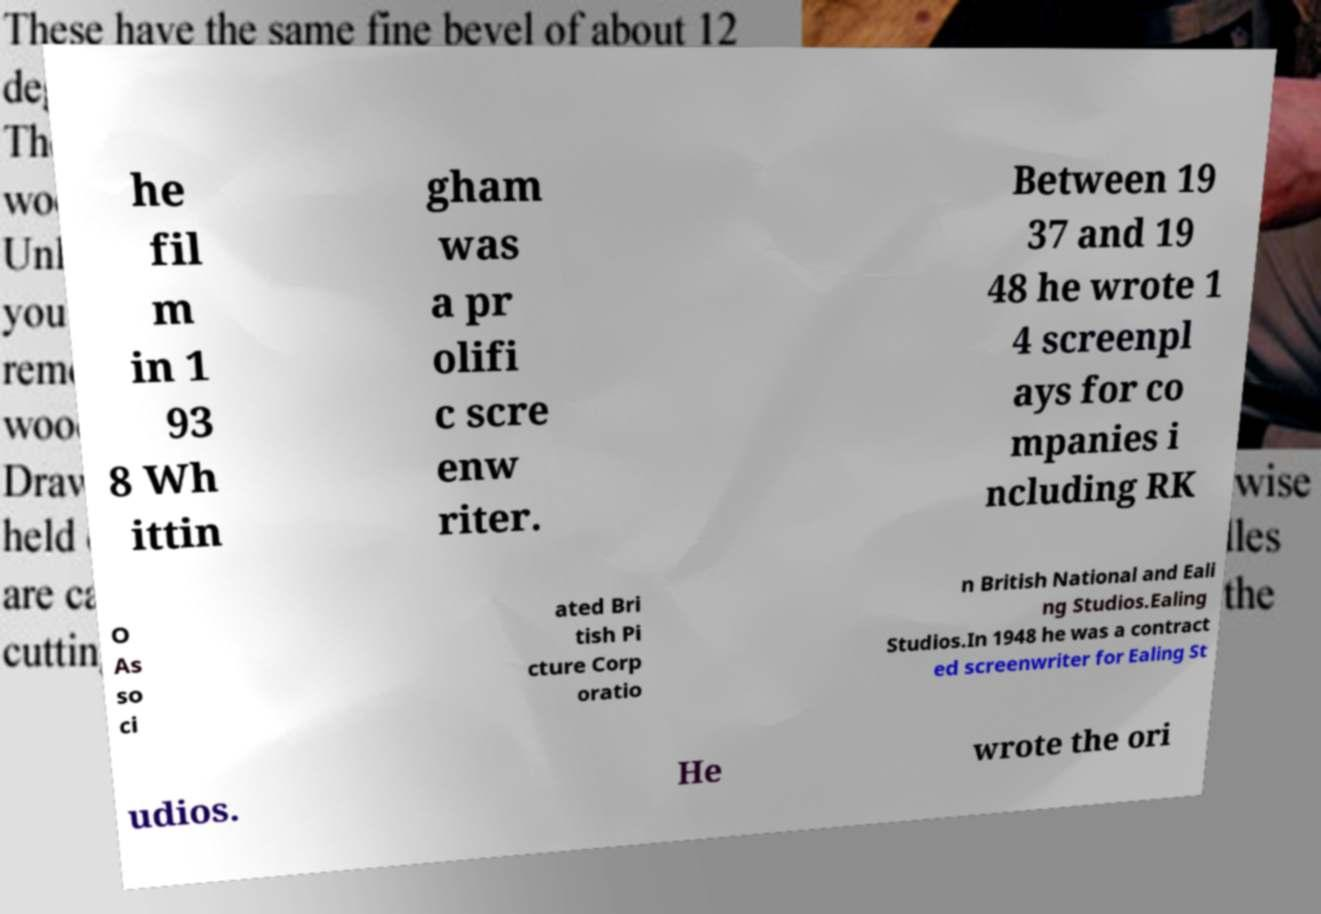There's text embedded in this image that I need extracted. Can you transcribe it verbatim? he fil m in 1 93 8 Wh ittin gham was a pr olifi c scre enw riter. Between 19 37 and 19 48 he wrote 1 4 screenpl ays for co mpanies i ncluding RK O As so ci ated Bri tish Pi cture Corp oratio n British National and Eali ng Studios.Ealing Studios.In 1948 he was a contract ed screenwriter for Ealing St udios. He wrote the ori 